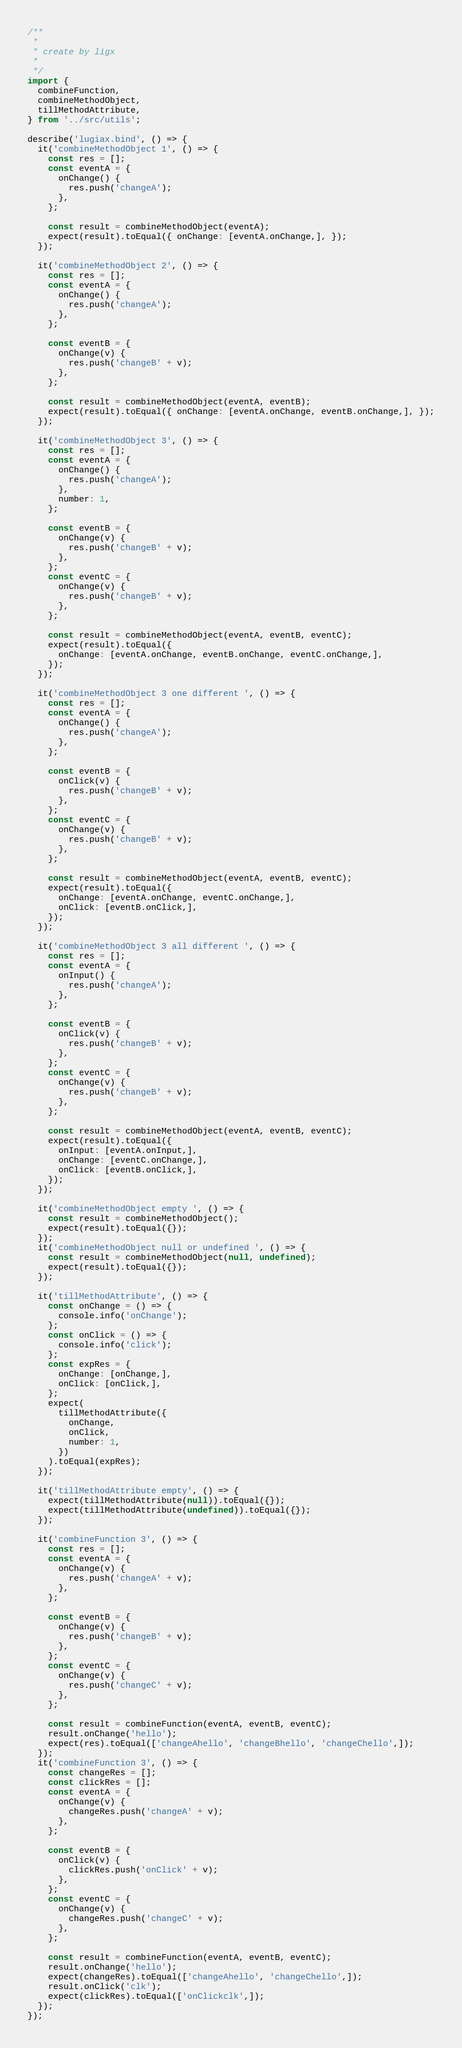Convert code to text. <code><loc_0><loc_0><loc_500><loc_500><_JavaScript_>/**
 *
 * create by ligx
 *
 */
import {
  combineFunction,
  combineMethodObject,
  tillMethodAttribute,
} from '../src/utils';

describe('lugiax.bind', () => {
  it('combineMethodObject 1', () => {
    const res = [];
    const eventA = {
      onChange() {
        res.push('changeA');
      },
    };

    const result = combineMethodObject(eventA);
    expect(result).toEqual({ onChange: [eventA.onChange,], });
  });

  it('combineMethodObject 2', () => {
    const res = [];
    const eventA = {
      onChange() {
        res.push('changeA');
      },
    };

    const eventB = {
      onChange(v) {
        res.push('changeB' + v);
      },
    };

    const result = combineMethodObject(eventA, eventB);
    expect(result).toEqual({ onChange: [eventA.onChange, eventB.onChange,], });
  });

  it('combineMethodObject 3', () => {
    const res = [];
    const eventA = {
      onChange() {
        res.push('changeA');
      },
      number: 1,
    };

    const eventB = {
      onChange(v) {
        res.push('changeB' + v);
      },
    };
    const eventC = {
      onChange(v) {
        res.push('changeB' + v);
      },
    };

    const result = combineMethodObject(eventA, eventB, eventC);
    expect(result).toEqual({
      onChange: [eventA.onChange, eventB.onChange, eventC.onChange,],
    });
  });

  it('combineMethodObject 3 one different ', () => {
    const res = [];
    const eventA = {
      onChange() {
        res.push('changeA');
      },
    };

    const eventB = {
      onClick(v) {
        res.push('changeB' + v);
      },
    };
    const eventC = {
      onChange(v) {
        res.push('changeB' + v);
      },
    };

    const result = combineMethodObject(eventA, eventB, eventC);
    expect(result).toEqual({
      onChange: [eventA.onChange, eventC.onChange,],
      onClick: [eventB.onClick,],
    });
  });

  it('combineMethodObject 3 all different ', () => {
    const res = [];
    const eventA = {
      onInput() {
        res.push('changeA');
      },
    };

    const eventB = {
      onClick(v) {
        res.push('changeB' + v);
      },
    };
    const eventC = {
      onChange(v) {
        res.push('changeB' + v);
      },
    };

    const result = combineMethodObject(eventA, eventB, eventC);
    expect(result).toEqual({
      onInput: [eventA.onInput,],
      onChange: [eventC.onChange,],
      onClick: [eventB.onClick,],
    });
  });

  it('combineMethodObject empty ', () => {
    const result = combineMethodObject();
    expect(result).toEqual({});
  });
  it('combineMethodObject null or undefined ', () => {
    const result = combineMethodObject(null, undefined);
    expect(result).toEqual({});
  });

  it('tillMethodAttribute', () => {
    const onChange = () => {
      console.info('onChange');
    };
    const onClick = () => {
      console.info('click');
    };
    const expRes = {
      onChange: [onChange,],
      onClick: [onClick,],
    };
    expect(
      tillMethodAttribute({
        onChange,
        onClick,
        number: 1,
      })
    ).toEqual(expRes);
  });

  it('tillMethodAttribute empty', () => {
    expect(tillMethodAttribute(null)).toEqual({});
    expect(tillMethodAttribute(undefined)).toEqual({});
  });

  it('combineFunction 3', () => {
    const res = [];
    const eventA = {
      onChange(v) {
        res.push('changeA' + v);
      },
    };

    const eventB = {
      onChange(v) {
        res.push('changeB' + v);
      },
    };
    const eventC = {
      onChange(v) {
        res.push('changeC' + v);
      },
    };

    const result = combineFunction(eventA, eventB, eventC);
    result.onChange('hello');
    expect(res).toEqual(['changeAhello', 'changeBhello', 'changeChello',]);
  });
  it('combineFunction 3', () => {
    const changeRes = [];
    const clickRes = [];
    const eventA = {
      onChange(v) {
        changeRes.push('changeA' + v);
      },
    };

    const eventB = {
      onClick(v) {
        clickRes.push('onClick' + v);
      },
    };
    const eventC = {
      onChange(v) {
        changeRes.push('changeC' + v);
      },
    };

    const result = combineFunction(eventA, eventB, eventC);
    result.onChange('hello');
    expect(changeRes).toEqual(['changeAhello', 'changeChello',]);
    result.onClick('clk');
    expect(clickRes).toEqual(['onClickclk',]);
  });
});
</code> 